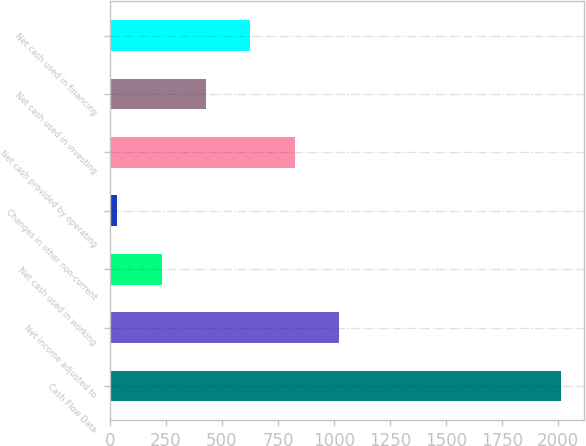Convert chart. <chart><loc_0><loc_0><loc_500><loc_500><bar_chart><fcel>Cash Flow Data<fcel>Net income adjusted to<fcel>Net cash used in working<fcel>Changes in other non-current<fcel>Net cash provided by operating<fcel>Net cash used in investing<fcel>Net cash used in financing<nl><fcel>2014<fcel>1023.7<fcel>231.46<fcel>33.4<fcel>825.64<fcel>429.52<fcel>627.58<nl></chart> 